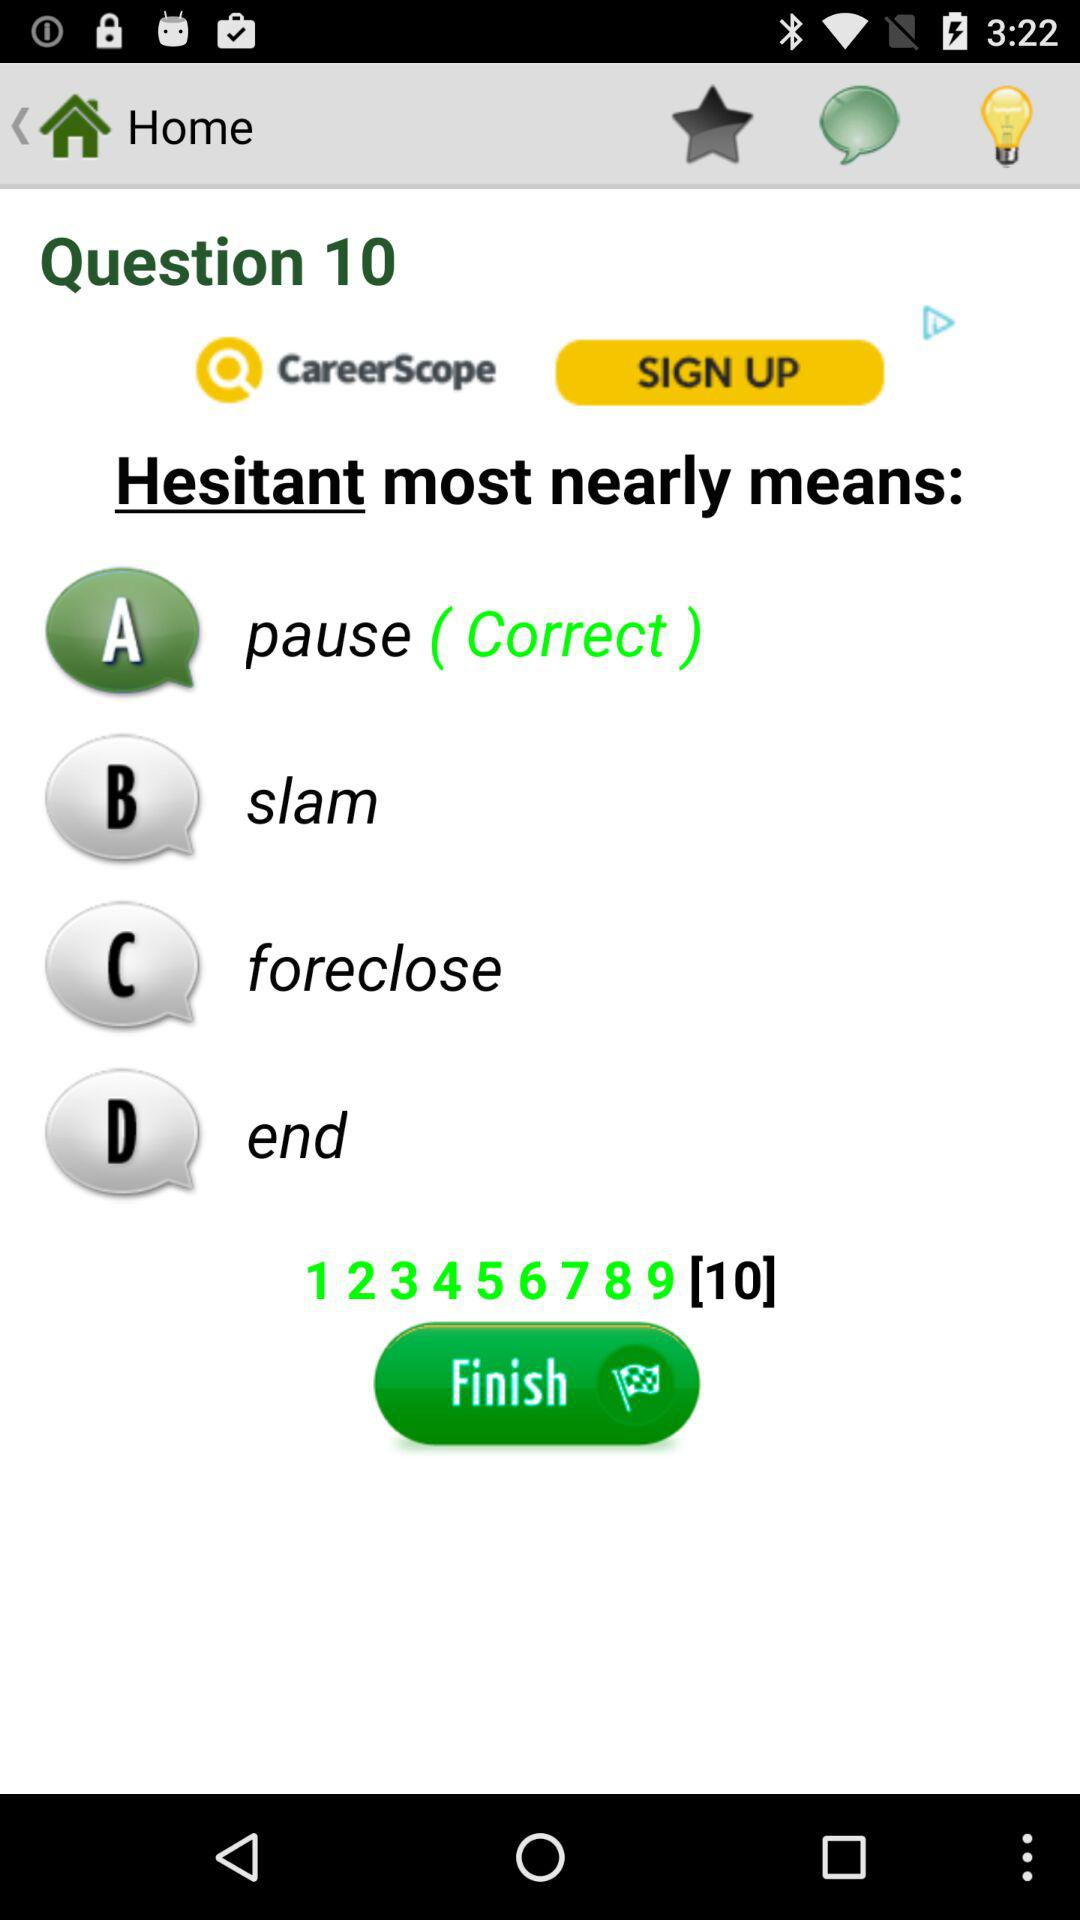At which question am I? You are at the 10th question. 